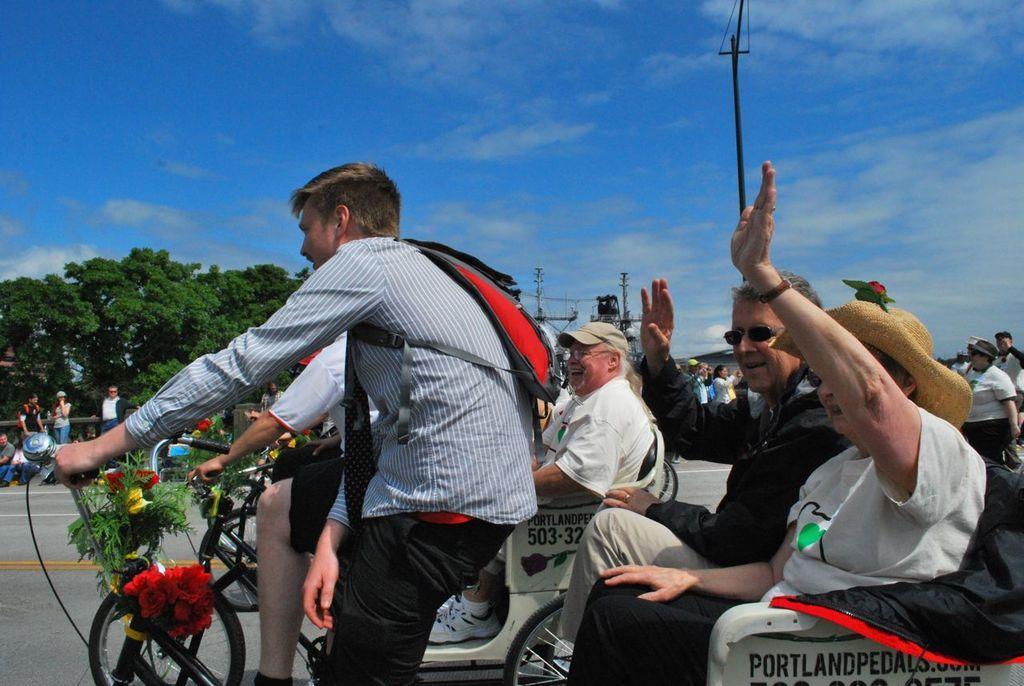In one or two sentences, can you explain what this image depicts? This image is taken in outdoors. In this there are many people. In the middle of the image a man is sitting on a vehicle and two of them were sitting at the back side of the vehicle a man and woman. At the bottom of the image there is a road. At the background there is a sky with clouds and there were many trees. 